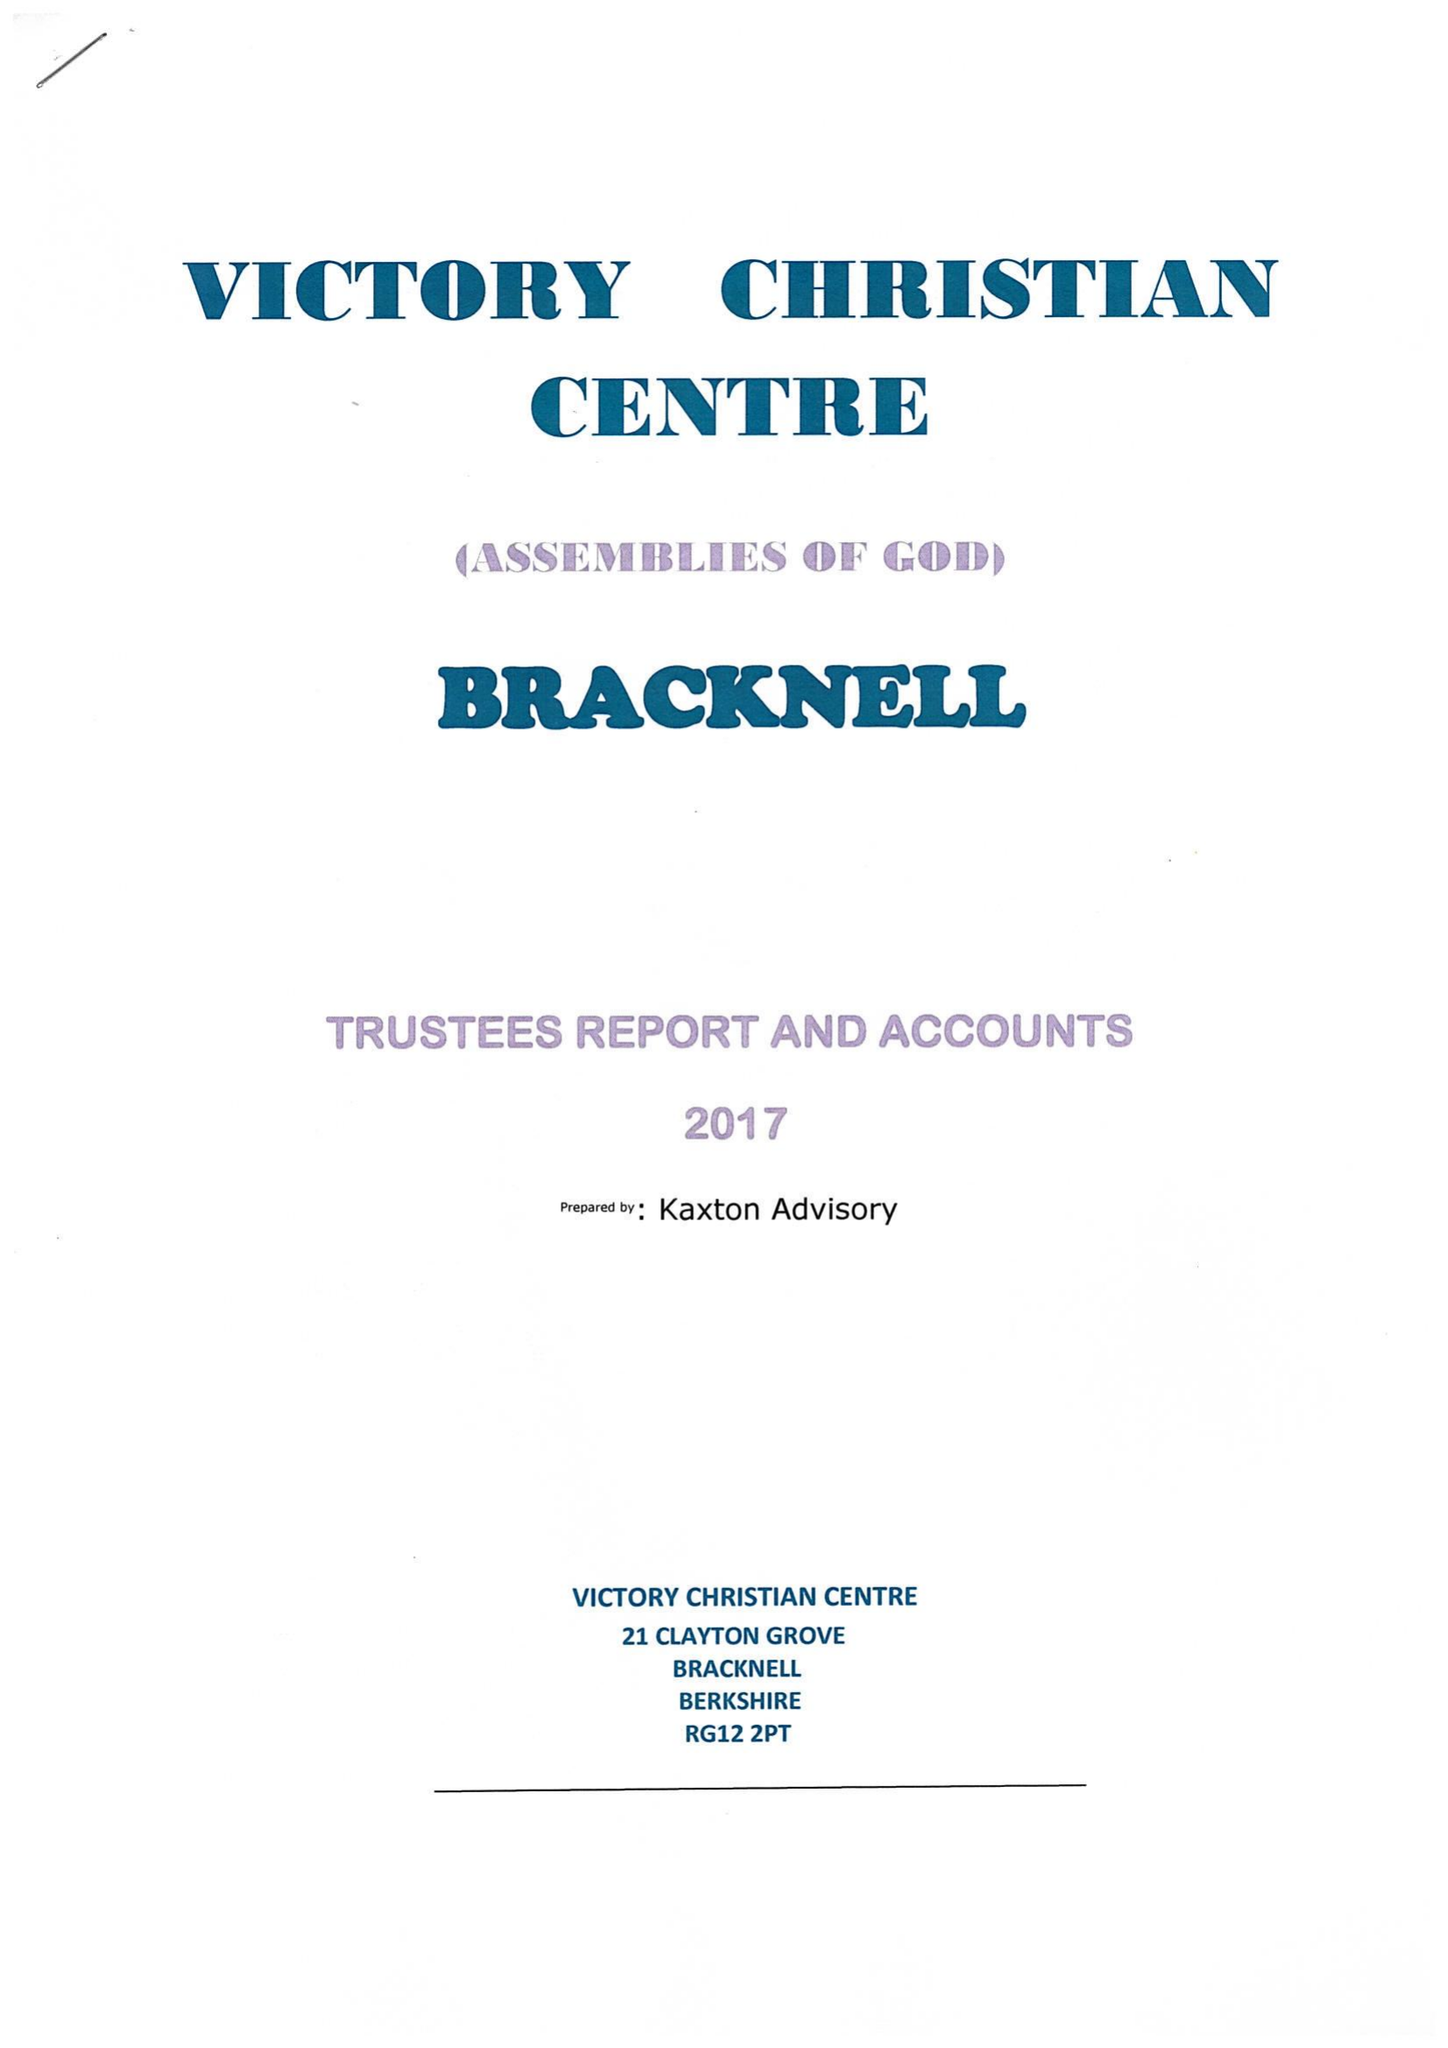What is the value for the report_date?
Answer the question using a single word or phrase. 2017-12-31 